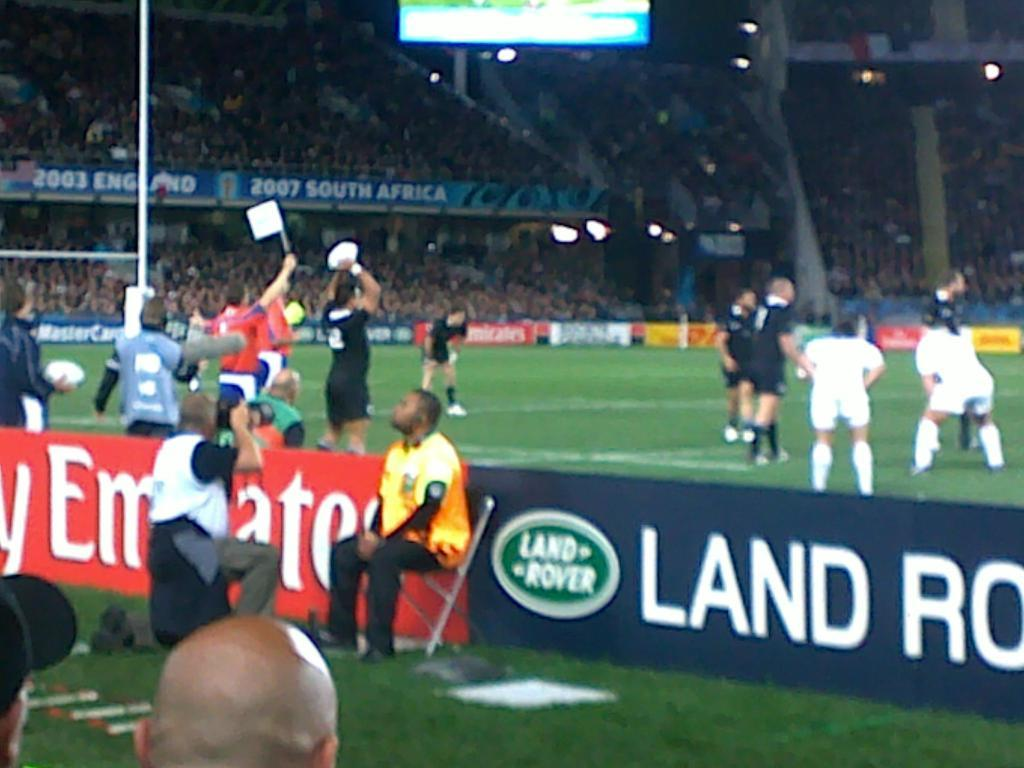<image>
Summarize the visual content of the image. A man wearing a yellow jersey sits on a chair near a Land Rover ad 